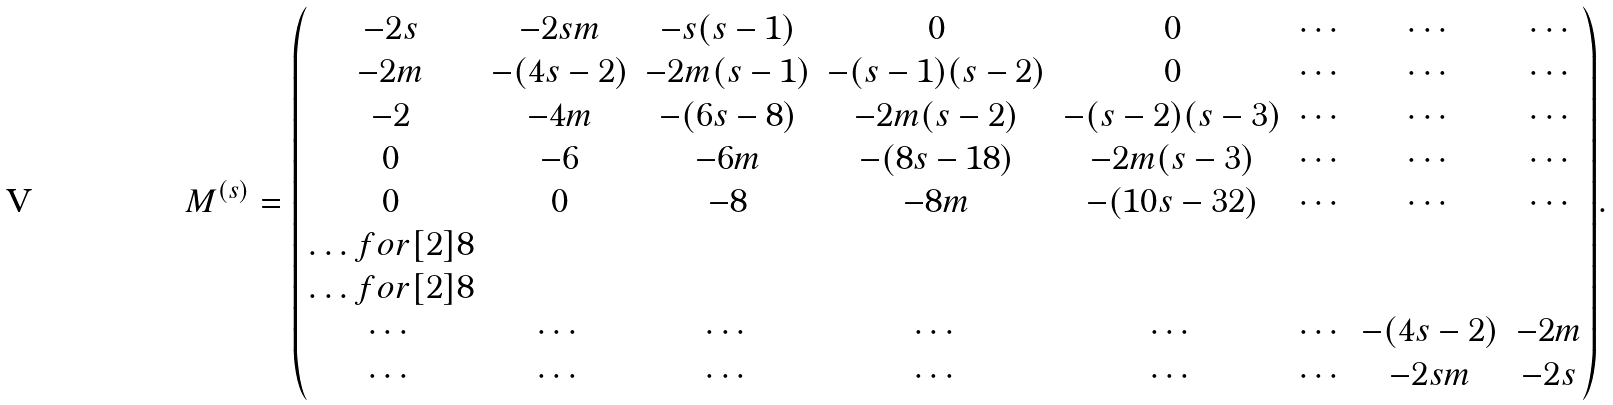Convert formula to latex. <formula><loc_0><loc_0><loc_500><loc_500>M ^ { ( s ) } = { \begin{pmatrix} - 2 s & - 2 s m & - s ( s - 1 ) & 0 & 0 & \cdots & \cdots & \cdots \\ - 2 m & - ( 4 s - 2 ) & - 2 m ( s - 1 ) & - ( s - 1 ) ( s - 2 ) & 0 & \cdots & \cdots & \cdots \\ - 2 & - 4 m & - ( 6 s - 8 ) & - 2 m ( s - 2 ) & - ( s - 2 ) ( s - 3 ) & \cdots & \cdots & \cdots \\ 0 & - 6 & - 6 m & - ( 8 s - 1 8 ) & - 2 m ( s - 3 ) & \cdots & \cdots & \cdots \\ 0 & 0 & - 8 & - 8 m & - ( 1 0 s - 3 2 ) & \cdots & \cdots & \cdots \\ \hdots f o r [ 2 ] { 8 } \\ \hdots f o r [ 2 ] { 8 } \\ \cdots & \cdots & \cdots & \cdots & \cdots & \cdots & - ( 4 s - 2 ) & - 2 m \\ \cdots & \cdots & \cdots & \cdots & \cdots & \cdots & - 2 s m & - 2 s \end{pmatrix} } .</formula> 